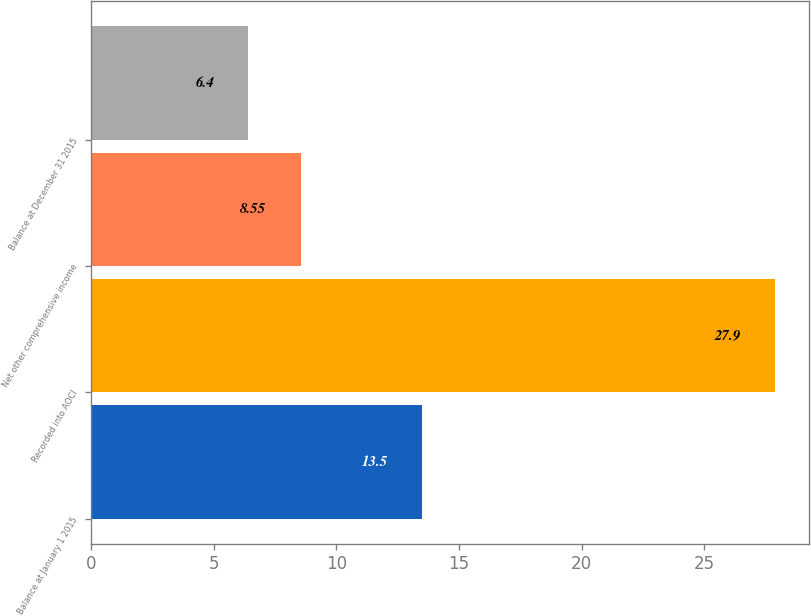Convert chart. <chart><loc_0><loc_0><loc_500><loc_500><bar_chart><fcel>Balance at January 1 2015<fcel>Recorded into AOCI<fcel>Net other comprehensive income<fcel>Balance at December 31 2015<nl><fcel>13.5<fcel>27.9<fcel>8.55<fcel>6.4<nl></chart> 